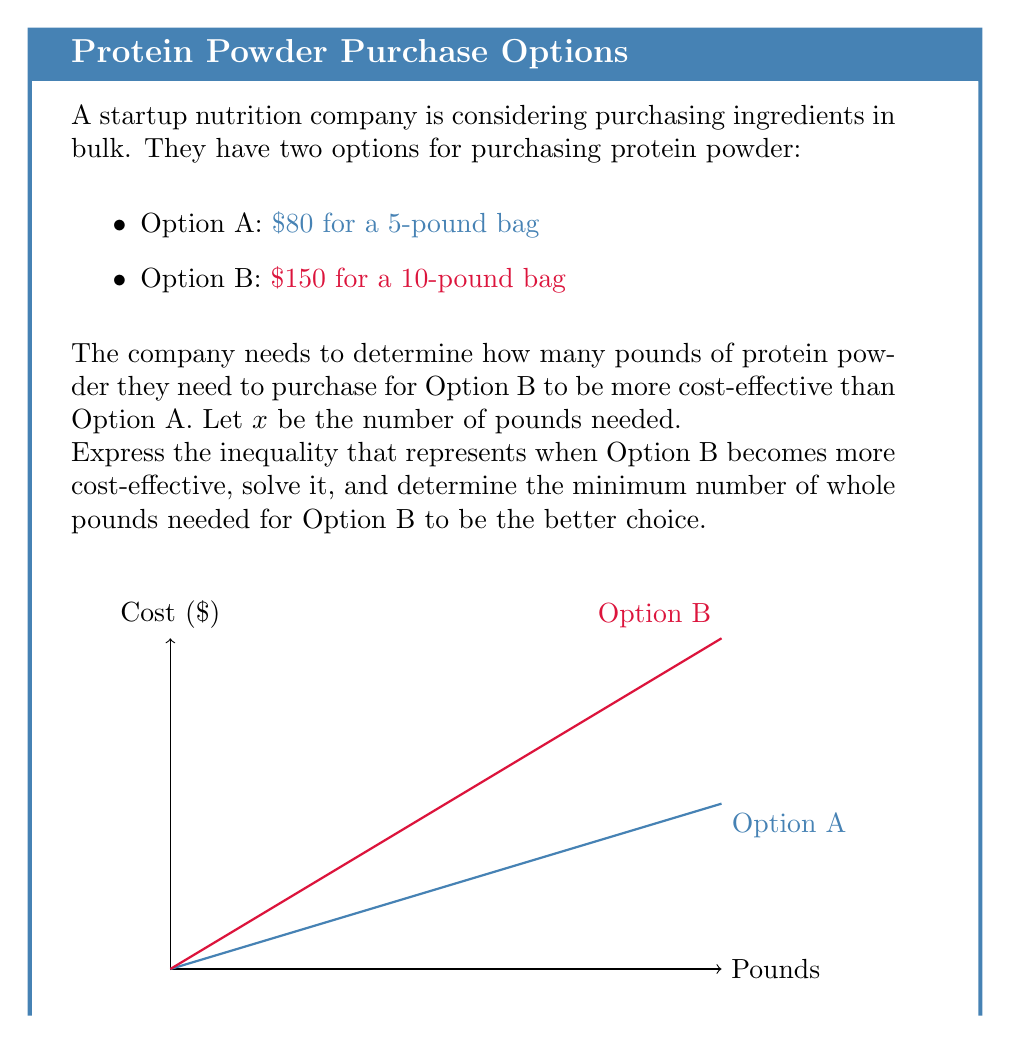Teach me how to tackle this problem. Let's approach this step-by-step:

1) First, we need to express the cost per pound for each option:

   Option A: $\frac{80}{5} = 16$ dollars per pound
   Option B: $\frac{150}{10} = 15$ dollars per pound

2) Now, let's set up the inequality. Option B is more cost-effective when:

   $\frac{150}{10}x < \frac{80}{5}x$

3) Simplify the fractions:

   $15x < 16x$

4) Subtract 15x from both sides:

   $0 < x$

5) This inequality is always true for positive values of x. However, we need to find the point where the total cost of Option B becomes less than Option A.

6) Set up the inequality for total cost:

   $150 < 80(\frac{x}{5})$

7) Multiply both sides by 5:

   $750 < 80x$

8) Divide both sides by 80:

   $\frac{750}{80} < x$

9) Simplify:

   $9.375 < x$

10) Since we're dealing with whole pounds, we need to round up to the next whole number.
Answer: 10 pounds 